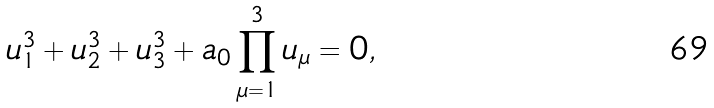<formula> <loc_0><loc_0><loc_500><loc_500>u _ { 1 } ^ { 3 } + u _ { 2 } ^ { 3 } + u _ { 3 } ^ { 3 } + a _ { 0 } \prod _ { \mu = 1 } ^ { 3 } u _ { \mu } = 0 ,</formula> 